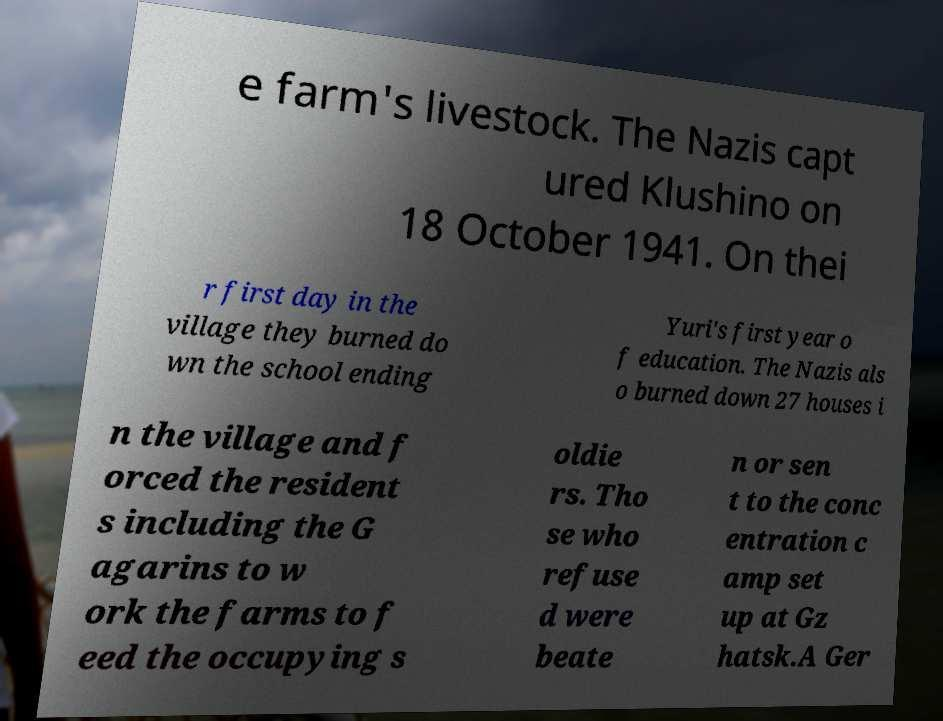Could you assist in decoding the text presented in this image and type it out clearly? e farm's livestock. The Nazis capt ured Klushino on 18 October 1941. On thei r first day in the village they burned do wn the school ending Yuri's first year o f education. The Nazis als o burned down 27 houses i n the village and f orced the resident s including the G agarins to w ork the farms to f eed the occupying s oldie rs. Tho se who refuse d were beate n or sen t to the conc entration c amp set up at Gz hatsk.A Ger 